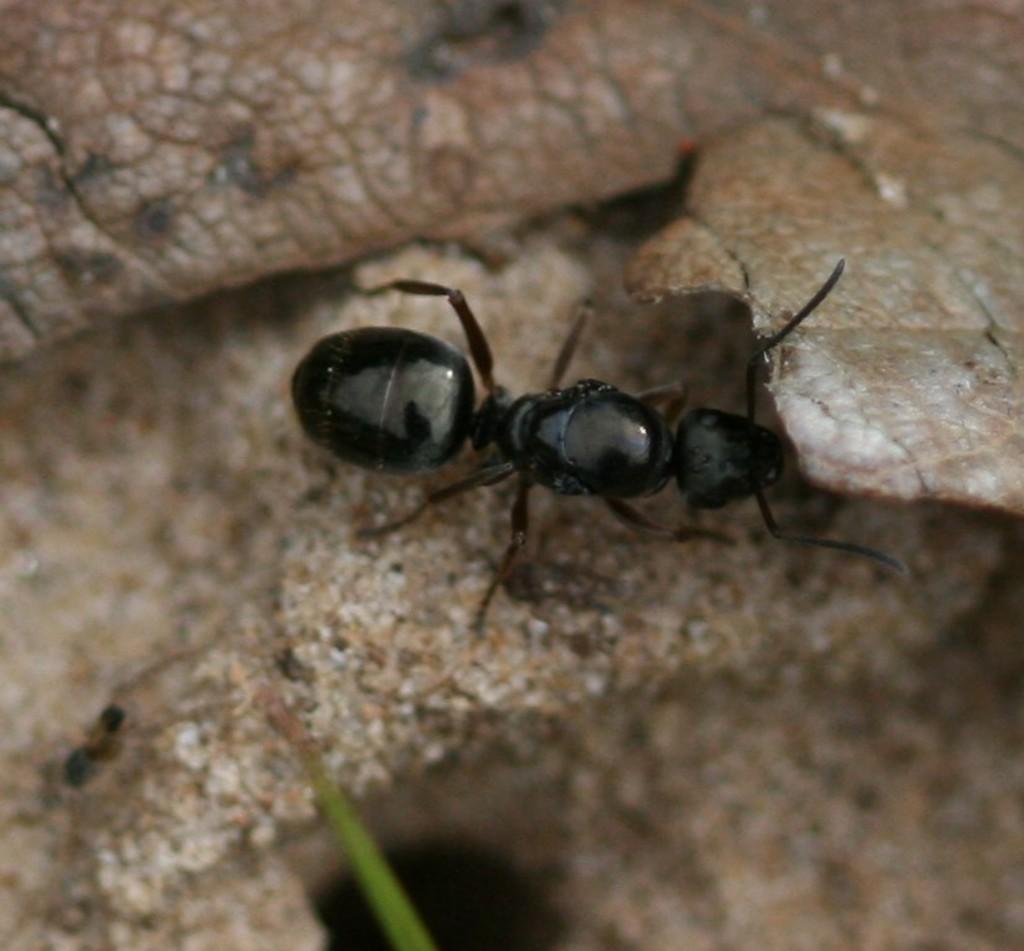Could you give a brief overview of what you see in this image? In this image I can see an insect and the insect is in black color. The insect is on the brown color surface and I can see some object in green color. 